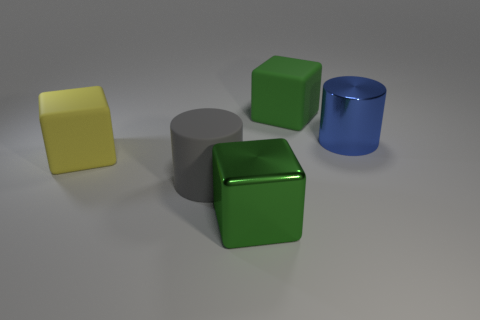Subtract all metal cubes. How many cubes are left? 2 Add 1 big metallic things. How many objects exist? 6 Subtract all green blocks. How many blocks are left? 1 Subtract 1 cylinders. How many cylinders are left? 1 Subtract all cylinders. How many objects are left? 3 Subtract all yellow cylinders. Subtract all yellow spheres. How many cylinders are left? 2 Subtract all brown blocks. How many purple cylinders are left? 0 Subtract all green matte objects. Subtract all big gray objects. How many objects are left? 3 Add 5 yellow blocks. How many yellow blocks are left? 6 Add 4 gray cylinders. How many gray cylinders exist? 5 